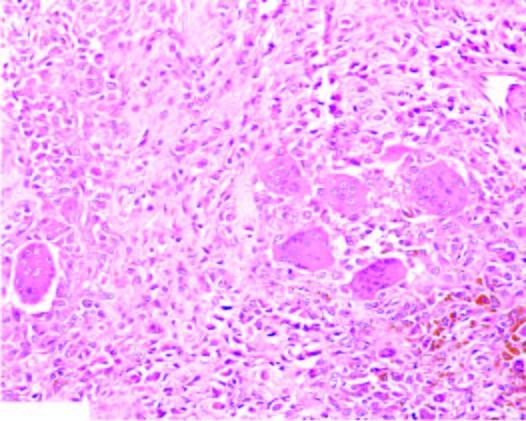how does the tumour show?
Answer the question using a single word or phrase. With numerous interspersed multinucleate giant cells lyning in a background of fibrous tissue 